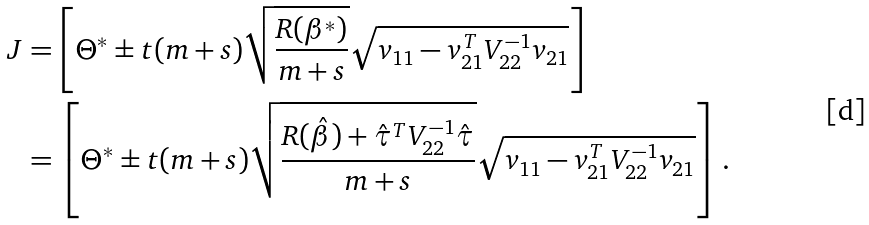<formula> <loc_0><loc_0><loc_500><loc_500>J & = \left [ \Theta ^ { * } \pm t ( m + s ) \sqrt { \frac { R ( \beta ^ { * } ) } { m + s } } \sqrt { v _ { 1 1 } - v _ { 2 1 } ^ { T } V _ { 2 2 } ^ { - 1 } v _ { 2 1 } } \right ] \\ & = \left [ \Theta ^ { * } \pm t ( m + s ) \sqrt { \frac { R ( \hat { \beta } ) + \hat { \tau } ^ { T } V _ { 2 2 } ^ { - 1 } \hat { \tau } } { m + s } } \sqrt { v _ { 1 1 } - v _ { 2 1 } ^ { T } V _ { 2 2 } ^ { - 1 } v _ { 2 1 } } \right ] .</formula> 